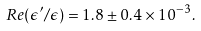Convert formula to latex. <formula><loc_0><loc_0><loc_500><loc_500>R e ( \epsilon ^ { \prime } / \epsilon ) = 1 . 8 \pm 0 . 4 \times 1 0 ^ { - 3 } .</formula> 